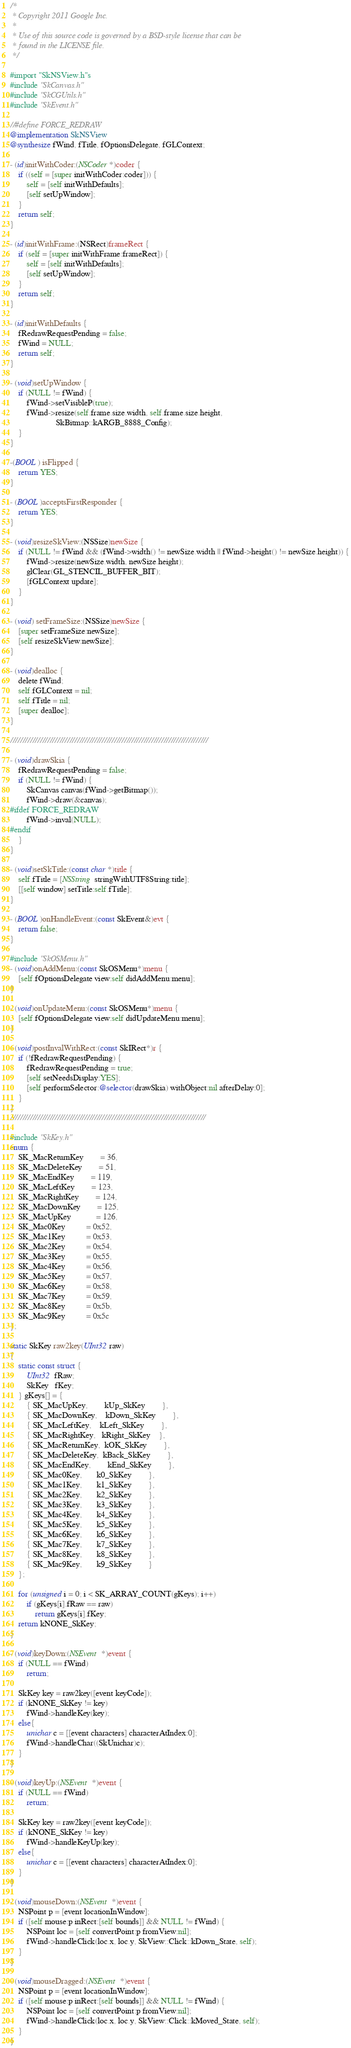Convert code to text. <code><loc_0><loc_0><loc_500><loc_500><_ObjectiveC_>
/*
 * Copyright 2011 Google Inc.
 *
 * Use of this source code is governed by a BSD-style license that can be
 * found in the LICENSE file.
 */

#import "SkNSView.h"s
#include "SkCanvas.h"
#include "SkCGUtils.h"
#include "SkEvent.h"

//#define FORCE_REDRAW
@implementation SkNSView
@synthesize fWind, fTitle, fOptionsDelegate, fGLContext;

- (id)initWithCoder:(NSCoder*)coder {
    if ((self = [super initWithCoder:coder])) {
        self = [self initWithDefaults];
        [self setUpWindow];
    }
    return self;
}

- (id)initWithFrame:(NSRect)frameRect {
    if (self = [super initWithFrame:frameRect]) {
        self = [self initWithDefaults];
        [self setUpWindow];
    }
    return self;
}

- (id)initWithDefaults {
    fRedrawRequestPending = false;
    fWind = NULL;
    return self;
}

- (void)setUpWindow {
    if (NULL != fWind) {
        fWind->setVisibleP(true);
        fWind->resize(self.frame.size.width, self.frame.size.height, 
                      SkBitmap::kARGB_8888_Config);
    }
}

-(BOOL) isFlipped {
    return YES;
}

- (BOOL)acceptsFirstResponder {
    return YES;
}

- (void)resizeSkView:(NSSize)newSize {
    if (NULL != fWind && (fWind->width() != newSize.width || fWind->height() != newSize.height)) {
        fWind->resize(newSize.width, newSize.height);
        glClear(GL_STENCIL_BUFFER_BIT);
        [fGLContext update];
    }
}

- (void) setFrameSize:(NSSize)newSize {
    [super setFrameSize:newSize];
    [self resizeSkView:newSize];
}

- (void)dealloc {
    delete fWind;
    self.fGLContext = nil;
    self.fTitle = nil;
    [super dealloc];
}

////////////////////////////////////////////////////////////////////////////////

- (void)drawSkia {
    fRedrawRequestPending = false;
    if (NULL != fWind) {
        SkCanvas canvas(fWind->getBitmap());
        fWind->draw(&canvas);
#ifdef FORCE_REDRAW
        fWind->inval(NULL);
#endif
    }
}

- (void)setSkTitle:(const char *)title {
    self.fTitle = [NSString stringWithUTF8String:title];
    [[self window] setTitle:self.fTitle];
}

- (BOOL)onHandleEvent:(const SkEvent&)evt {
    return false;
}

#include "SkOSMenu.h"
- (void)onAddMenu:(const SkOSMenu*)menu {
    [self.fOptionsDelegate view:self didAddMenu:menu];
}

- (void)onUpdateMenu:(const SkOSMenu*)menu {
    [self.fOptionsDelegate view:self didUpdateMenu:menu];
}

- (void)postInvalWithRect:(const SkIRect*)r {
    if (!fRedrawRequestPending) {
        fRedrawRequestPending = true;
        [self setNeedsDisplay:YES];
        [self performSelector:@selector(drawSkia) withObject:nil afterDelay:0];
    }
}
///////////////////////////////////////////////////////////////////////////////

#include "SkKey.h"
enum {
	SK_MacReturnKey		= 36,
	SK_MacDeleteKey		= 51,
	SK_MacEndKey		= 119,
	SK_MacLeftKey		= 123,
	SK_MacRightKey		= 124,
	SK_MacDownKey		= 125,
	SK_MacUpKey			= 126,
    SK_Mac0Key          = 0x52,
    SK_Mac1Key          = 0x53,
    SK_Mac2Key          = 0x54,
    SK_Mac3Key          = 0x55,
    SK_Mac4Key          = 0x56,
    SK_Mac5Key          = 0x57,
    SK_Mac6Key          = 0x58,
    SK_Mac7Key          = 0x59,
    SK_Mac8Key          = 0x5b,
    SK_Mac9Key          = 0x5c
};

static SkKey raw2key(UInt32 raw)
{
	static const struct {
		UInt32  fRaw;
		SkKey   fKey;
	} gKeys[] = {
		{ SK_MacUpKey,		kUp_SkKey		},
		{ SK_MacDownKey,	kDown_SkKey		},
		{ SK_MacLeftKey,	kLeft_SkKey		},
		{ SK_MacRightKey,   kRight_SkKey	},
		{ SK_MacReturnKey,  kOK_SkKey		},
		{ SK_MacDeleteKey,  kBack_SkKey		},
		{ SK_MacEndKey,		kEnd_SkKey		},
        { SK_Mac0Key,       k0_SkKey        },
        { SK_Mac1Key,       k1_SkKey        },
        { SK_Mac2Key,       k2_SkKey        },
        { SK_Mac3Key,       k3_SkKey        },
        { SK_Mac4Key,       k4_SkKey        },
        { SK_Mac5Key,       k5_SkKey        },
        { SK_Mac6Key,       k6_SkKey        },
        { SK_Mac7Key,       k7_SkKey        },
        { SK_Mac8Key,       k8_SkKey        },
        { SK_Mac9Key,       k9_SkKey        }
	};
    
	for (unsigned i = 0; i < SK_ARRAY_COUNT(gKeys); i++)
		if (gKeys[i].fRaw == raw)
			return gKeys[i].fKey;
	return kNONE_SkKey;
}

- (void)keyDown:(NSEvent *)event {
    if (NULL == fWind)
        return;
    
    SkKey key = raw2key([event keyCode]);
    if (kNONE_SkKey != key)
        fWind->handleKey(key);
    else{
        unichar c = [[event characters] characterAtIndex:0];
        fWind->handleChar((SkUnichar)c);
    }
}

- (void)keyUp:(NSEvent *)event {
    if (NULL == fWind)
        return;
    
    SkKey key = raw2key([event keyCode]);
    if (kNONE_SkKey != key)
        fWind->handleKeyUp(key);
    else{
        unichar c = [[event characters] characterAtIndex:0];
    }
}

- (void)mouseDown:(NSEvent *)event {
    NSPoint p = [event locationInWindow];
    if ([self mouse:p inRect:[self bounds]] && NULL != fWind) {
        NSPoint loc = [self convertPoint:p fromView:nil];
        fWind->handleClick(loc.x, loc.y, SkView::Click::kDown_State, self);
    }
}

- (void)mouseDragged:(NSEvent *)event {
    NSPoint p = [event locationInWindow];
    if ([self mouse:p inRect:[self bounds]] && NULL != fWind) {
        NSPoint loc = [self convertPoint:p fromView:nil];
        fWind->handleClick(loc.x, loc.y, SkView::Click::kMoved_State, self);
    }
}
</code> 